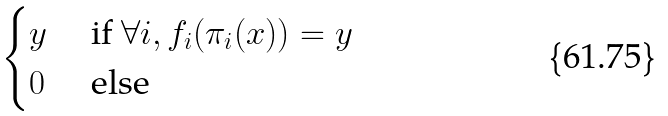Convert formula to latex. <formula><loc_0><loc_0><loc_500><loc_500>\begin{cases} y & \text { if } \forall i , f _ { i } ( \pi _ { i } ( x ) ) = y \\ 0 & \text { else} \end{cases}</formula> 